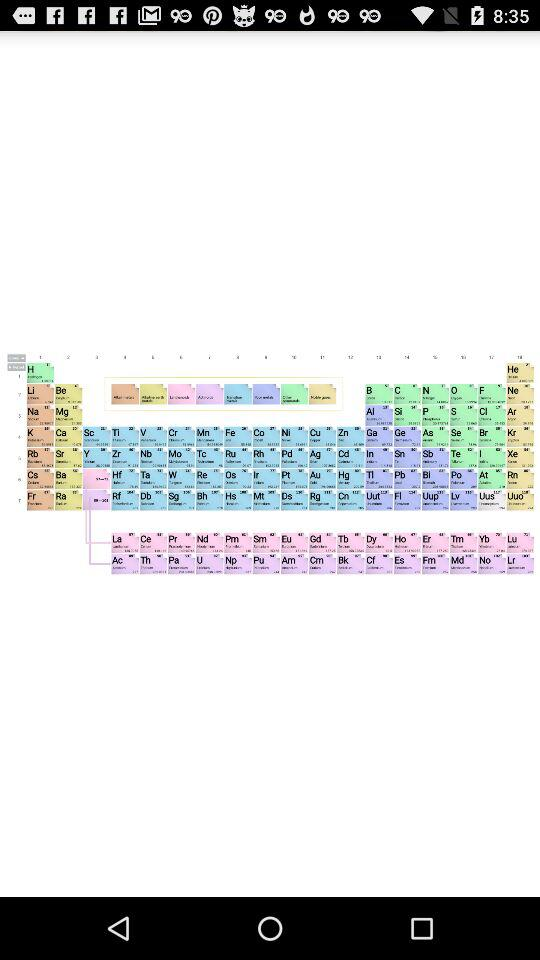How many downloads does the app have?
Answer the question using a single word or phrase. 200 thousand 